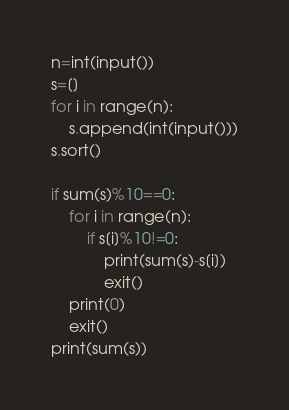<code> <loc_0><loc_0><loc_500><loc_500><_Python_>n=int(input())
s=[]
for i in range(n):
    s.append(int(input()))
s.sort()

if sum(s)%10==0:
    for i in range(n):
        if s[i]%10!=0:
            print(sum(s)-s[i])
            exit()
    print(0)
    exit()
print(sum(s))
</code> 